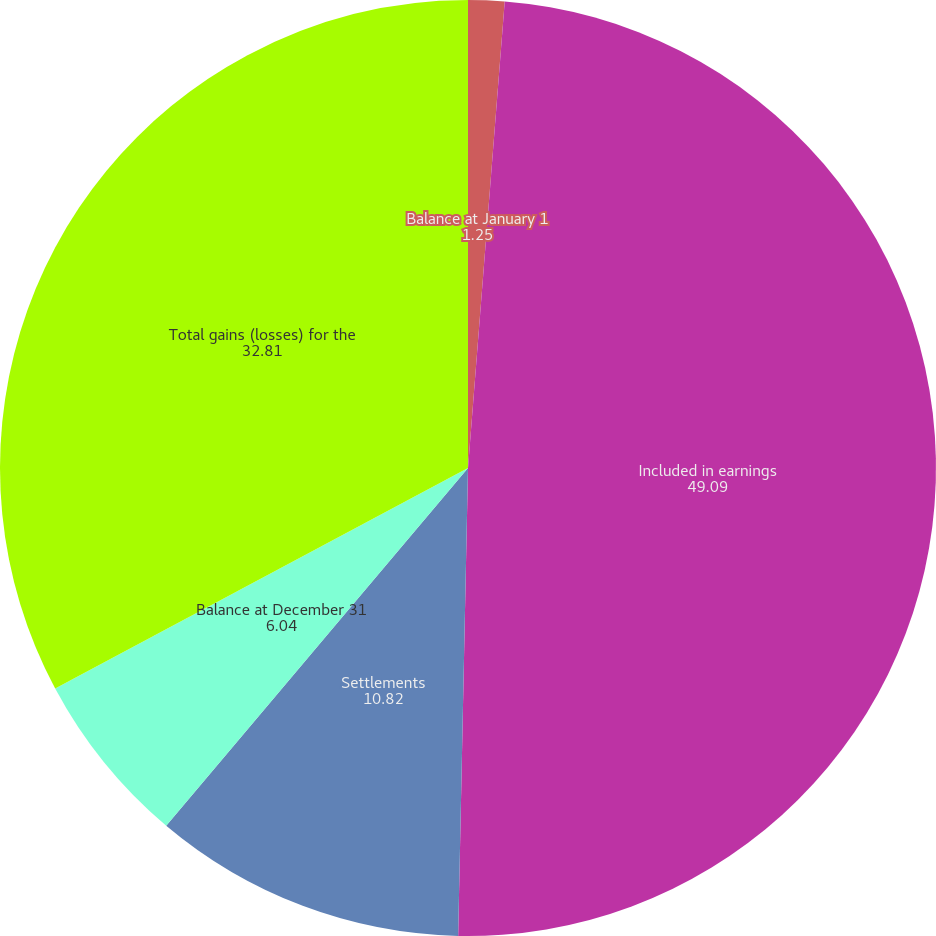<chart> <loc_0><loc_0><loc_500><loc_500><pie_chart><fcel>Balance at January 1<fcel>Included in earnings<fcel>Settlements<fcel>Balance at December 31<fcel>Total gains (losses) for the<nl><fcel>1.25%<fcel>49.09%<fcel>10.82%<fcel>6.04%<fcel>32.81%<nl></chart> 